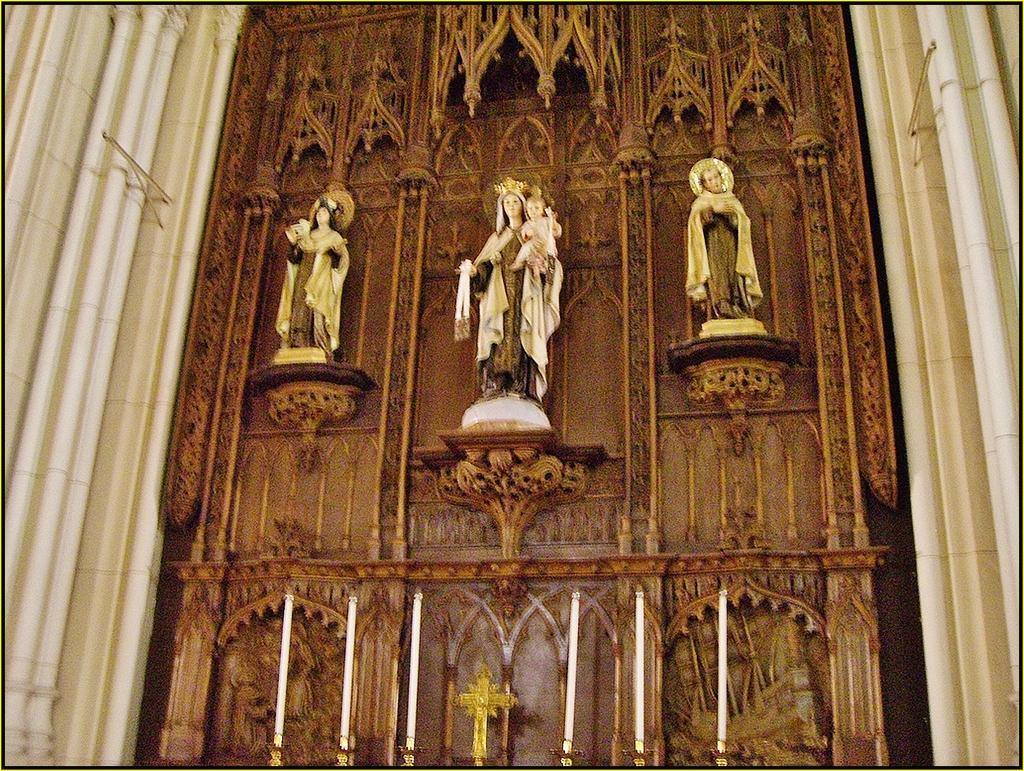Describe this image in one or two sentences. In this image we can see statues to the wall, pillars, candles and candle holders. 